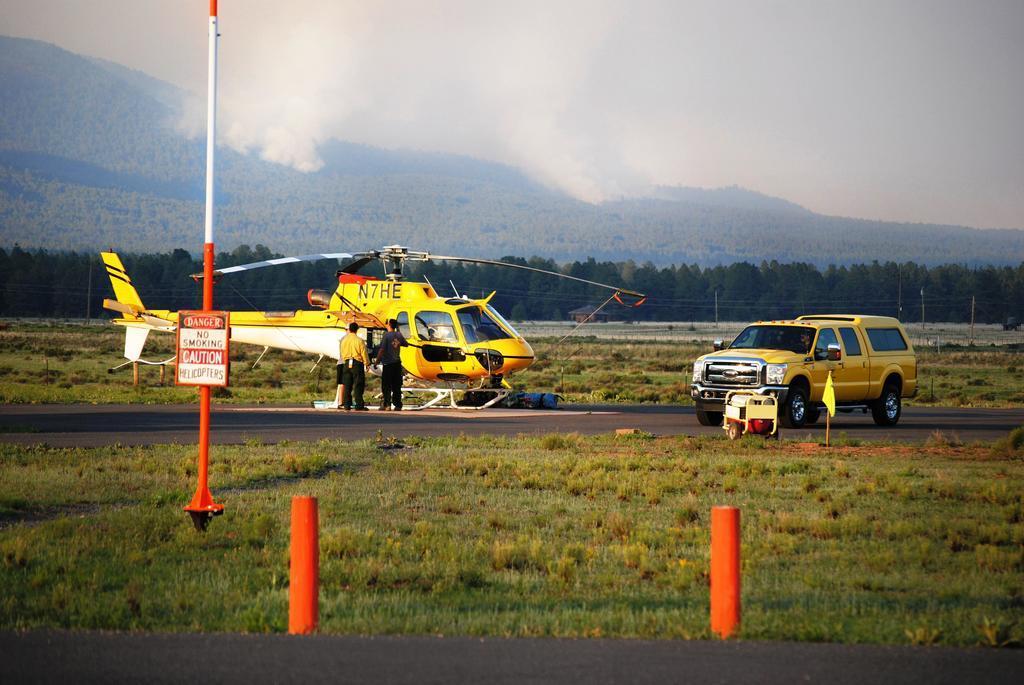Can you describe this image briefly? In the foreground of the image we can see the grass. In the middle of the image we can see a helicopter, car and two persons are standing. On the top of the image we can see the sky and trees. 